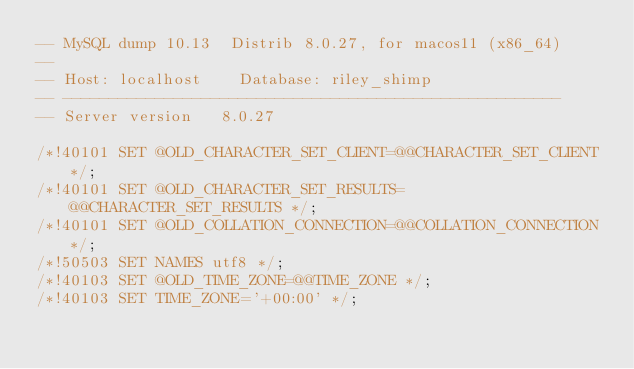Convert code to text. <code><loc_0><loc_0><loc_500><loc_500><_SQL_>-- MySQL dump 10.13  Distrib 8.0.27, for macos11 (x86_64)
--
-- Host: localhost    Database: riley_shimp
-- ------------------------------------------------------
-- Server version	8.0.27

/*!40101 SET @OLD_CHARACTER_SET_CLIENT=@@CHARACTER_SET_CLIENT */;
/*!40101 SET @OLD_CHARACTER_SET_RESULTS=@@CHARACTER_SET_RESULTS */;
/*!40101 SET @OLD_COLLATION_CONNECTION=@@COLLATION_CONNECTION */;
/*!50503 SET NAMES utf8 */;
/*!40103 SET @OLD_TIME_ZONE=@@TIME_ZONE */;
/*!40103 SET TIME_ZONE='+00:00' */;</code> 